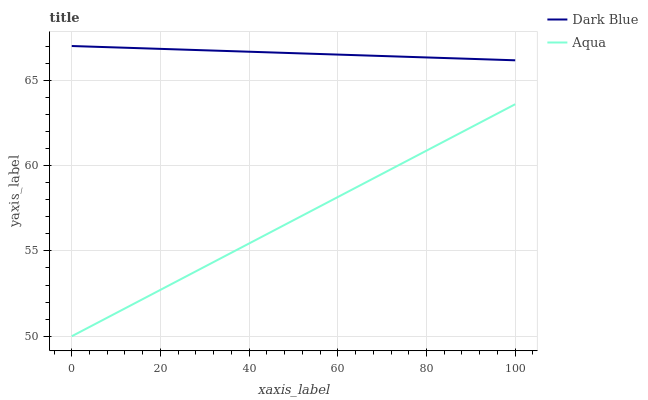Does Aqua have the minimum area under the curve?
Answer yes or no. Yes. Does Dark Blue have the maximum area under the curve?
Answer yes or no. Yes. Does Aqua have the maximum area under the curve?
Answer yes or no. No. Is Aqua the smoothest?
Answer yes or no. Yes. Is Dark Blue the roughest?
Answer yes or no. Yes. Is Aqua the roughest?
Answer yes or no. No. Does Aqua have the lowest value?
Answer yes or no. Yes. Does Dark Blue have the highest value?
Answer yes or no. Yes. Does Aqua have the highest value?
Answer yes or no. No. Is Aqua less than Dark Blue?
Answer yes or no. Yes. Is Dark Blue greater than Aqua?
Answer yes or no. Yes. Does Aqua intersect Dark Blue?
Answer yes or no. No. 